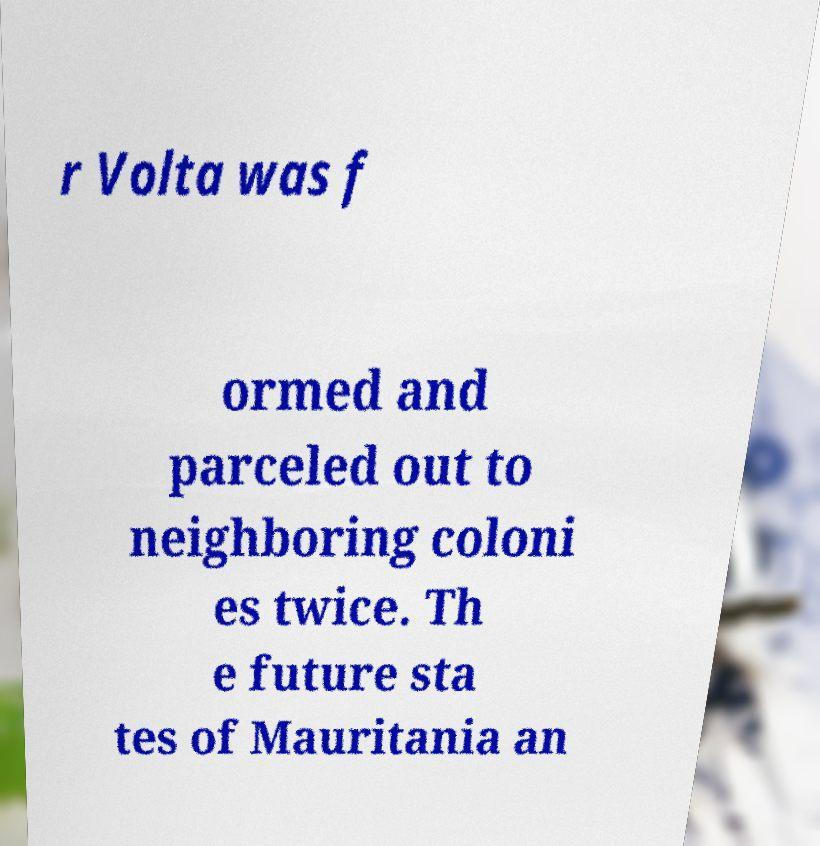I need the written content from this picture converted into text. Can you do that? r Volta was f ormed and parceled out to neighboring coloni es twice. Th e future sta tes of Mauritania an 